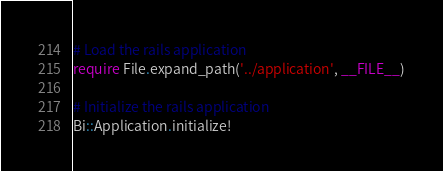Convert code to text. <code><loc_0><loc_0><loc_500><loc_500><_Ruby_># Load the rails application
require File.expand_path('../application', __FILE__)

# Initialize the rails application
Bi::Application.initialize!
</code> 